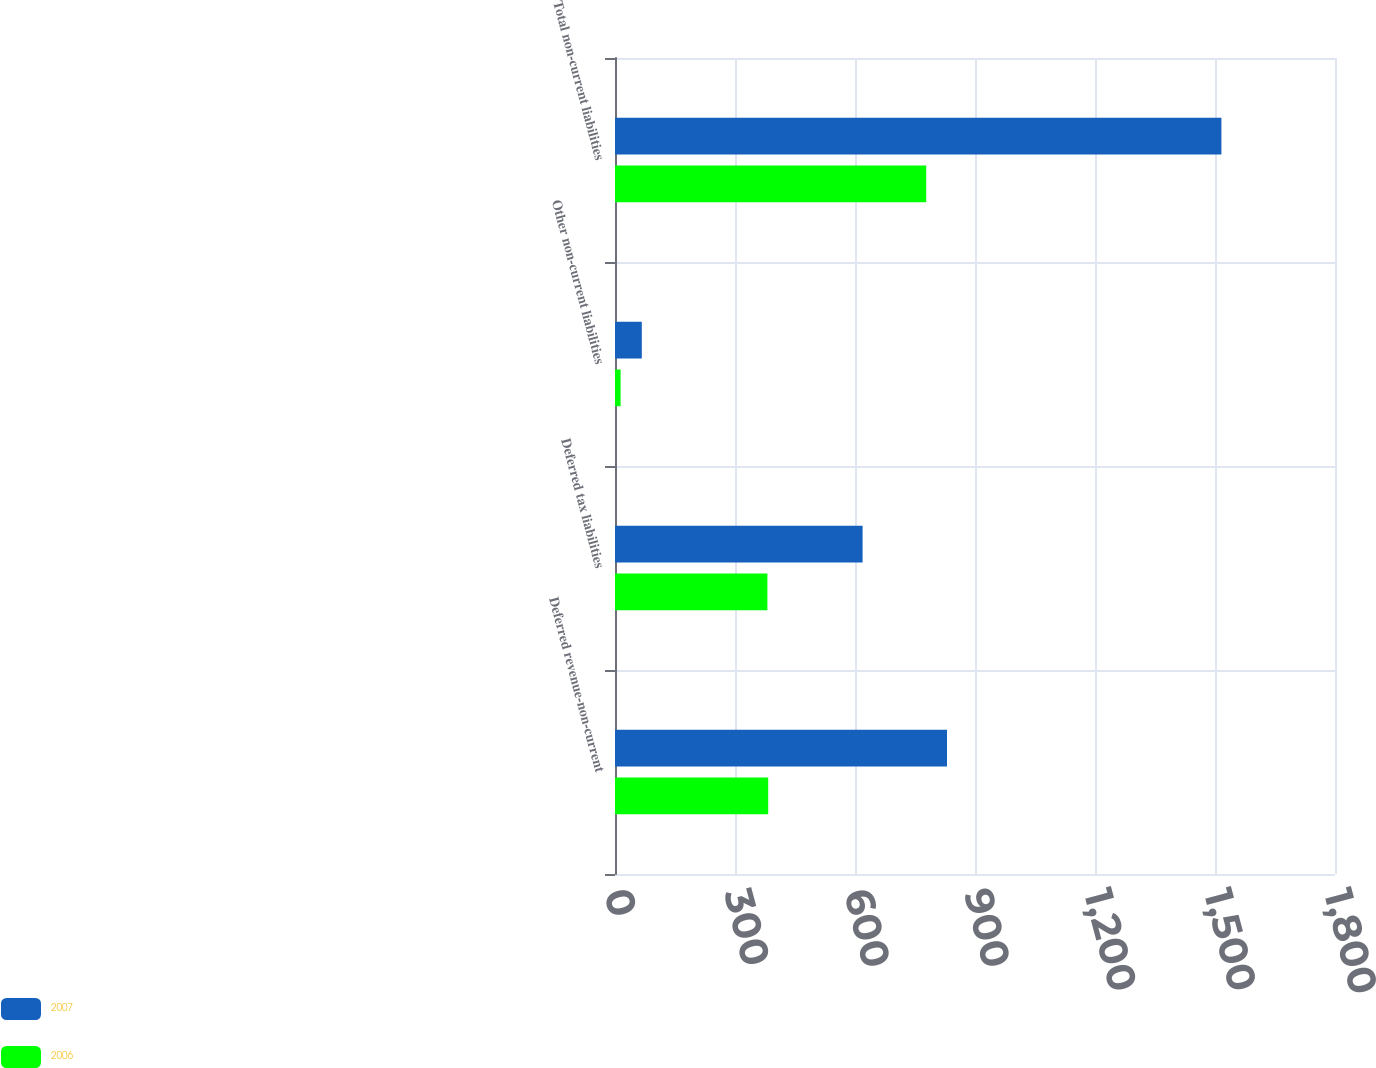Convert chart to OTSL. <chart><loc_0><loc_0><loc_500><loc_500><stacked_bar_chart><ecel><fcel>Deferred revenue-non-current<fcel>Deferred tax liabilities<fcel>Other non-current liabilities<fcel>Total non-current liabilities<nl><fcel>2007<fcel>830<fcel>619<fcel>67<fcel>1516<nl><fcel>2006<fcel>383<fcel>381<fcel>14<fcel>778<nl></chart> 